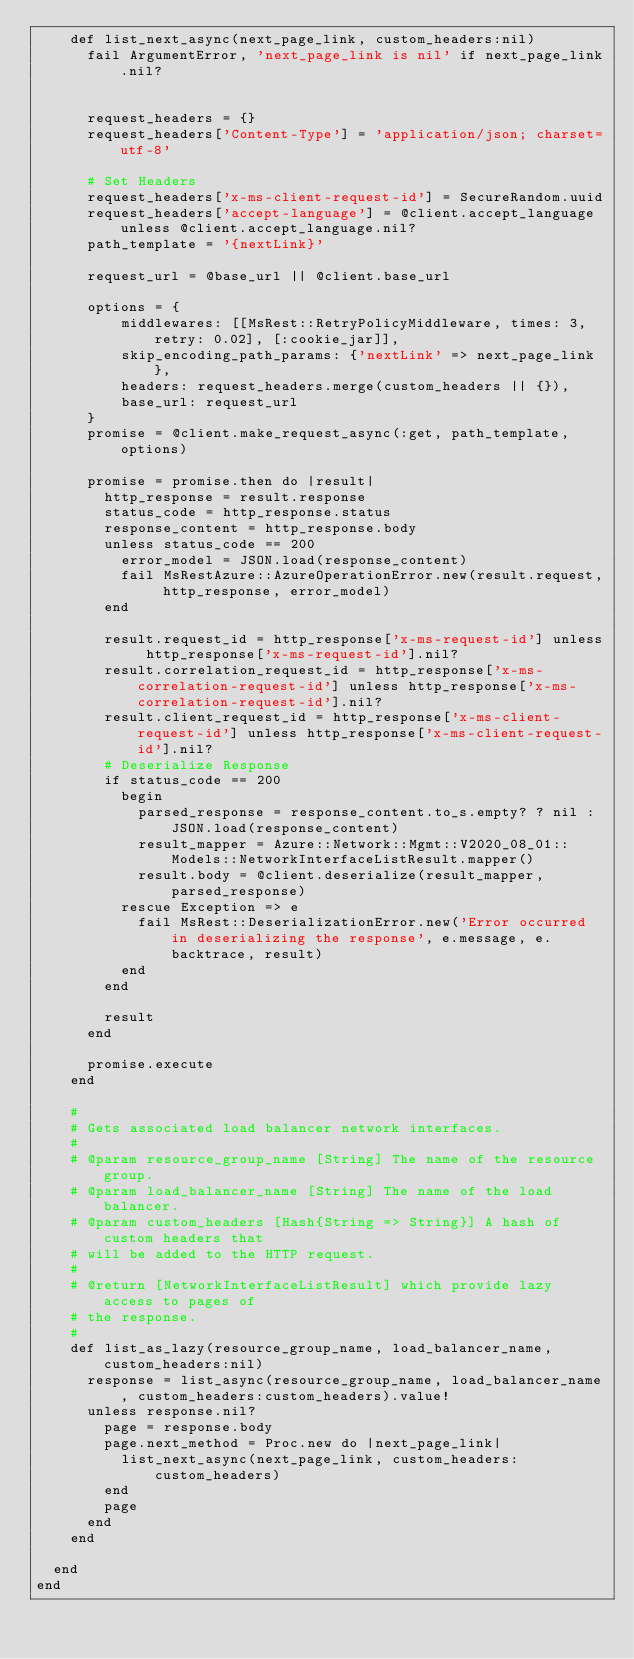Convert code to text. <code><loc_0><loc_0><loc_500><loc_500><_Ruby_>    def list_next_async(next_page_link, custom_headers:nil)
      fail ArgumentError, 'next_page_link is nil' if next_page_link.nil?


      request_headers = {}
      request_headers['Content-Type'] = 'application/json; charset=utf-8'

      # Set Headers
      request_headers['x-ms-client-request-id'] = SecureRandom.uuid
      request_headers['accept-language'] = @client.accept_language unless @client.accept_language.nil?
      path_template = '{nextLink}'

      request_url = @base_url || @client.base_url

      options = {
          middlewares: [[MsRest::RetryPolicyMiddleware, times: 3, retry: 0.02], [:cookie_jar]],
          skip_encoding_path_params: {'nextLink' => next_page_link},
          headers: request_headers.merge(custom_headers || {}),
          base_url: request_url
      }
      promise = @client.make_request_async(:get, path_template, options)

      promise = promise.then do |result|
        http_response = result.response
        status_code = http_response.status
        response_content = http_response.body
        unless status_code == 200
          error_model = JSON.load(response_content)
          fail MsRestAzure::AzureOperationError.new(result.request, http_response, error_model)
        end

        result.request_id = http_response['x-ms-request-id'] unless http_response['x-ms-request-id'].nil?
        result.correlation_request_id = http_response['x-ms-correlation-request-id'] unless http_response['x-ms-correlation-request-id'].nil?
        result.client_request_id = http_response['x-ms-client-request-id'] unless http_response['x-ms-client-request-id'].nil?
        # Deserialize Response
        if status_code == 200
          begin
            parsed_response = response_content.to_s.empty? ? nil : JSON.load(response_content)
            result_mapper = Azure::Network::Mgmt::V2020_08_01::Models::NetworkInterfaceListResult.mapper()
            result.body = @client.deserialize(result_mapper, parsed_response)
          rescue Exception => e
            fail MsRest::DeserializationError.new('Error occurred in deserializing the response', e.message, e.backtrace, result)
          end
        end

        result
      end

      promise.execute
    end

    #
    # Gets associated load balancer network interfaces.
    #
    # @param resource_group_name [String] The name of the resource group.
    # @param load_balancer_name [String] The name of the load balancer.
    # @param custom_headers [Hash{String => String}] A hash of custom headers that
    # will be added to the HTTP request.
    #
    # @return [NetworkInterfaceListResult] which provide lazy access to pages of
    # the response.
    #
    def list_as_lazy(resource_group_name, load_balancer_name, custom_headers:nil)
      response = list_async(resource_group_name, load_balancer_name, custom_headers:custom_headers).value!
      unless response.nil?
        page = response.body
        page.next_method = Proc.new do |next_page_link|
          list_next_async(next_page_link, custom_headers:custom_headers)
        end
        page
      end
    end

  end
end
</code> 